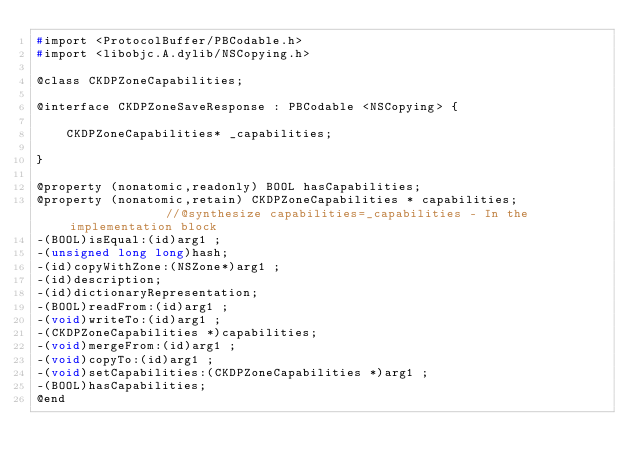Convert code to text. <code><loc_0><loc_0><loc_500><loc_500><_C_>#import <ProtocolBuffer/PBCodable.h>
#import <libobjc.A.dylib/NSCopying.h>

@class CKDPZoneCapabilities;

@interface CKDPZoneSaveResponse : PBCodable <NSCopying> {

	CKDPZoneCapabilities* _capabilities;

}

@property (nonatomic,readonly) BOOL hasCapabilities; 
@property (nonatomic,retain) CKDPZoneCapabilities * capabilities;              //@synthesize capabilities=_capabilities - In the implementation block
-(BOOL)isEqual:(id)arg1 ;
-(unsigned long long)hash;
-(id)copyWithZone:(NSZone*)arg1 ;
-(id)description;
-(id)dictionaryRepresentation;
-(BOOL)readFrom:(id)arg1 ;
-(void)writeTo:(id)arg1 ;
-(CKDPZoneCapabilities *)capabilities;
-(void)mergeFrom:(id)arg1 ;
-(void)copyTo:(id)arg1 ;
-(void)setCapabilities:(CKDPZoneCapabilities *)arg1 ;
-(BOOL)hasCapabilities;
@end

</code> 